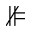<formula> <loc_0><loc_0><loc_500><loc_500>\nVDash</formula> 